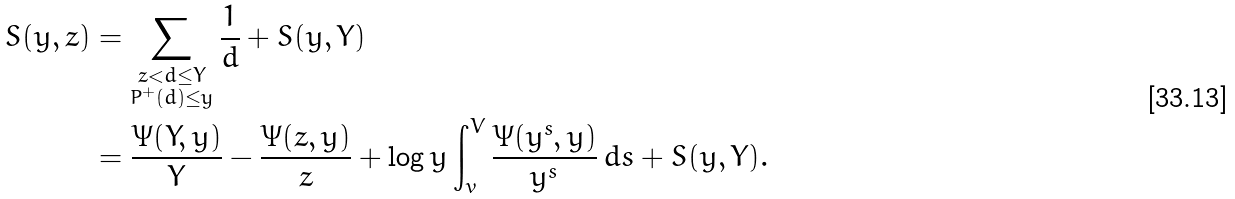Convert formula to latex. <formula><loc_0><loc_0><loc_500><loc_500>S ( y , z ) & = \sum _ { \substack { z < d \leq Y \\ P ^ { + } ( d ) \leq y } } \frac { 1 } { d } + S ( y , Y ) \\ & = \frac { \Psi ( Y , y ) } { Y } - \frac { \Psi ( z , y ) } { z } + \log y \int _ { v } ^ { V } \frac { \Psi ( y ^ { s } , y ) } { y ^ { s } } \, d s + S ( y , Y ) .</formula> 